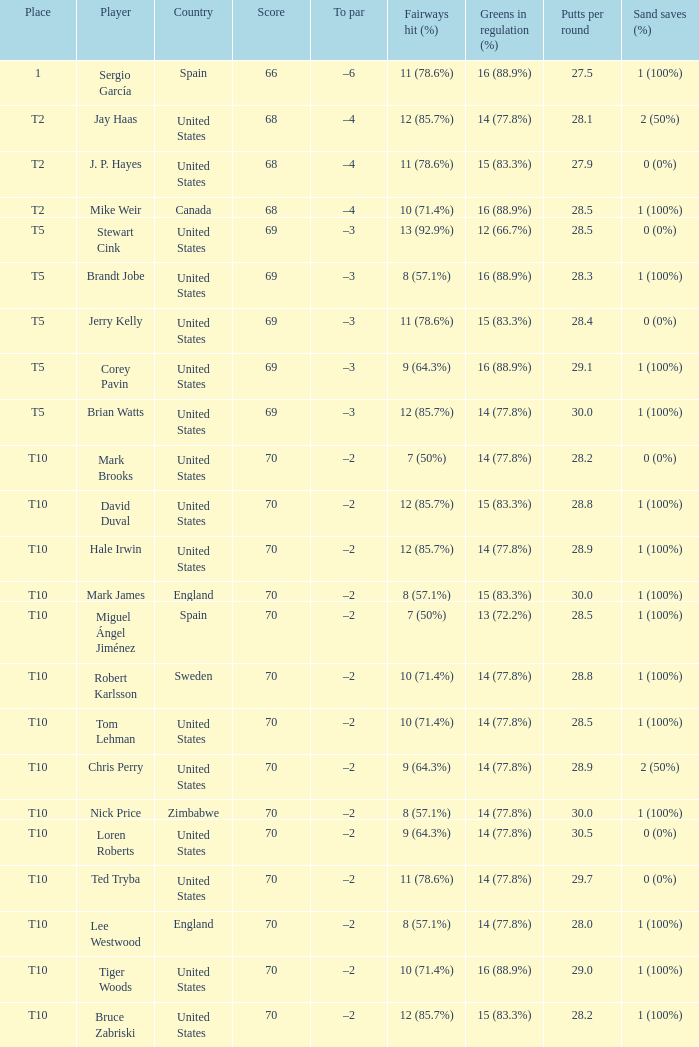What place did player mark brooks take? T10. 